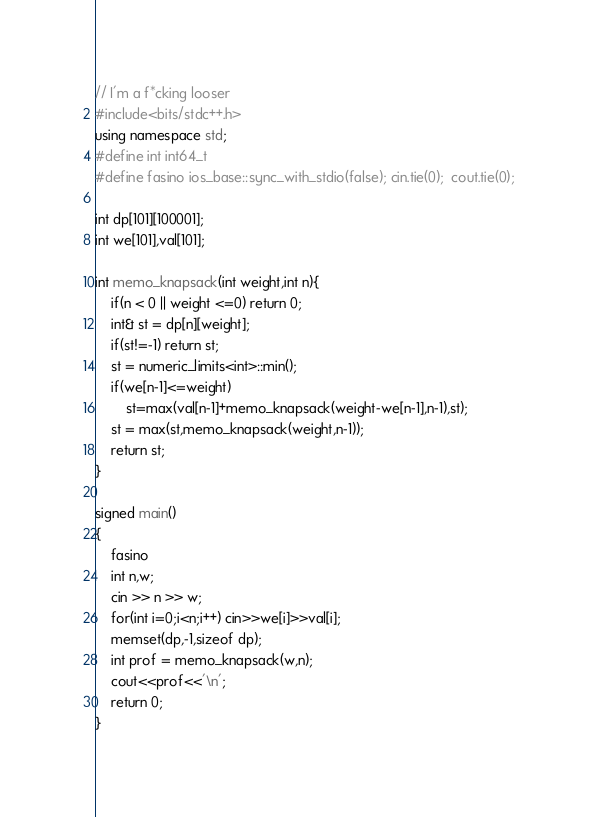Convert code to text. <code><loc_0><loc_0><loc_500><loc_500><_C++_>// I'm a f*cking looser
#include<bits/stdc++.h>
using namespace std;
#define int int64_t
#define fasino ios_base::sync_with_stdio(false); cin.tie(0);  cout.tie(0);

int dp[101][100001];
int we[101],val[101];

int memo_knapsack(int weight,int n){
    if(n < 0 || weight <=0) return 0;
    int& st = dp[n][weight];
    if(st!=-1) return st;
    st = numeric_limits<int>::min();
    if(we[n-1]<=weight)
        st=max(val[n-1]+memo_knapsack(weight-we[n-1],n-1),st);
    st = max(st,memo_knapsack(weight,n-1));
    return st;
} 

signed main()
{
    fasino
    int n,w;
    cin >> n >> w;
    for(int i=0;i<n;i++) cin>>we[i]>>val[i];
    memset(dp,-1,sizeof dp);
    int prof = memo_knapsack(w,n);
    cout<<prof<<'\n';
    return 0;
}
</code> 